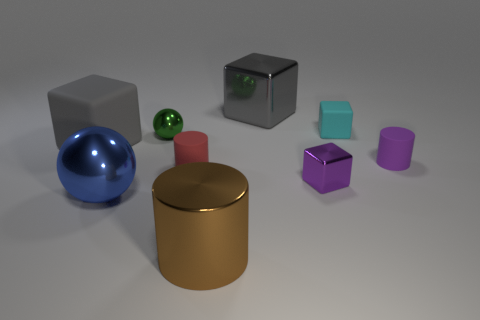Subtract all brown balls. How many gray blocks are left? 2 Subtract all small red cylinders. How many cylinders are left? 2 Add 1 blue shiny things. How many objects exist? 10 Subtract all purple cubes. How many cubes are left? 3 Subtract 2 blocks. How many blocks are left? 2 Subtract all cyan blocks. Subtract all brown cylinders. How many blocks are left? 3 Add 1 purple rubber things. How many purple rubber things exist? 2 Subtract 1 brown cylinders. How many objects are left? 8 Subtract all cylinders. How many objects are left? 6 Subtract all cyan matte cylinders. Subtract all gray blocks. How many objects are left? 7 